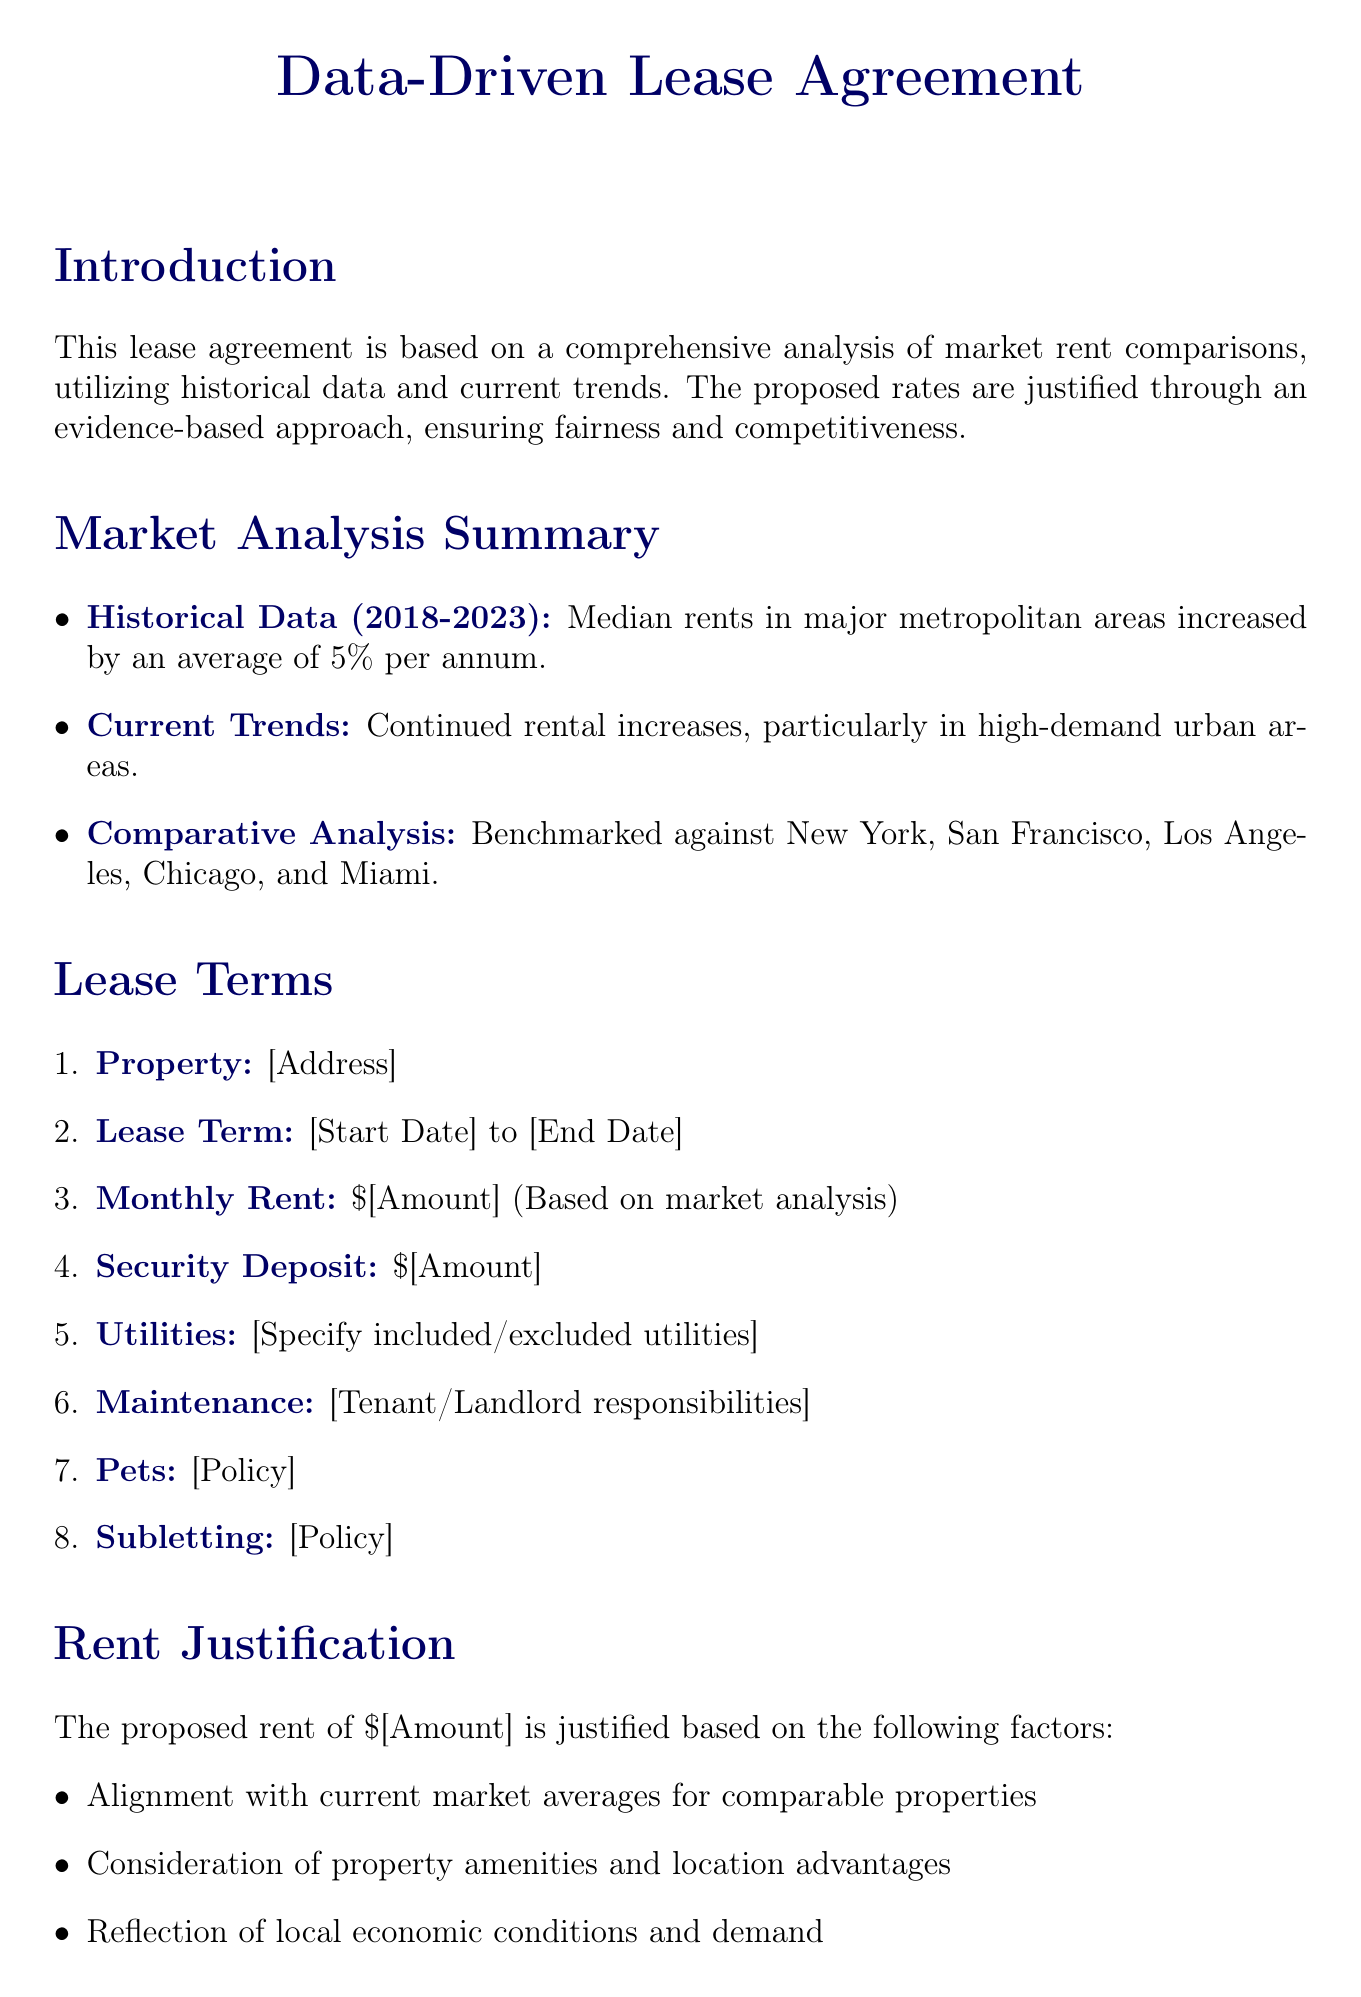What is the lease term duration? The lease term duration is indicated between the start date and end date specified in the document.
Answer: [Start Date] to [End Date] What is the monthly rent proposed? The proposed monthly rent is specified as an amount that is determined based on market analysis.
Answer: $[Amount] What was the median rent in Austin? The median rent for Austin is provided in the market data snapshot section of the document.
Answer: $1,800 What has been the YoY change in rent in San Francisco? The year-over-year (YoY) change for San Francisco is listed in the market data snapshot of the document.
Answer: 2.5% increase What factors justify the proposed rent? Justification for the proposed rent is based on several factors mentioned in the rent justification section.
Answer: Current market averages, property amenities, local economic conditions What is the role of historical data in this lease agreement? The historical data is summarized to provide insight into rent trends and inform the proposed rates in the lease agreement.
Answer: Median rents increased by an average of 5% per annum Which cities were compared in the comparative analysis? The document lists multiple major metropolitan areas that serve as benchmarks for the analysis.
Answer: New York, San Francisco, Los Angeles, Chicago, Miami What is the security deposit amount? The security deposit amount is specified in the lease terms section of the agreement.
Answer: $[Amount] 